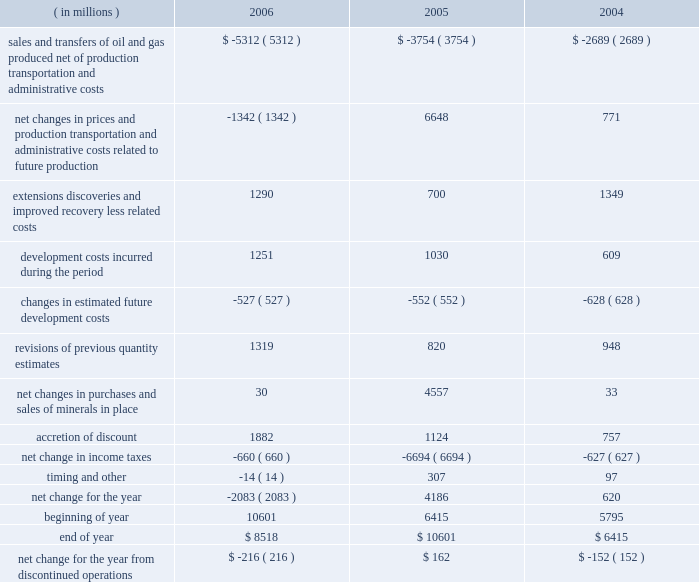Supplementary information on oil and gas producing activities ( unaudited ) c o n t i n u e d summary of changes in standardized measure of discounted future net cash flows relating to proved oil and gas reserves ( in millions ) 2006 2005 2004 sales and transfers of oil and gas produced , net of production , transportation and administrative costs $ ( 5312 ) $ ( 3754 ) $ ( 2689 ) net changes in prices and production , transportation and administrative costs related to future production ( 1342 ) 6648 771 .

If the 2007 year shows the same rate of change as 2006 , what would the projected ending cash flow balance be , in millions? 
Computations: ((8518 / 10601) * 8518)
Answer: 6844.29054. 